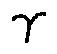Convert formula to latex. <formula><loc_0><loc_0><loc_500><loc_500>\gamma</formula> 